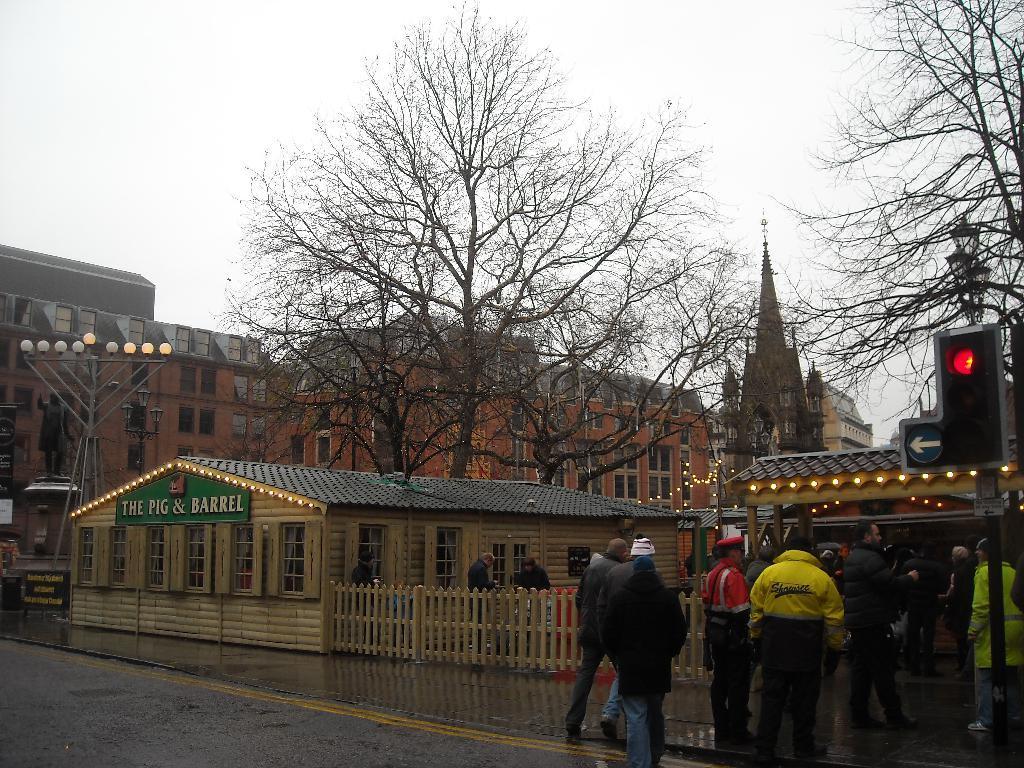Could you give a brief overview of what you see in this image? Here in this picture we can see shops present in the front and behind them we can see buildings present all over there and we can see trees present here and there and we can see lamp posts and traffic signal lights on poles here and there and we can see sign boards also present here and there and we can see people standing and walking on the road here and there. 